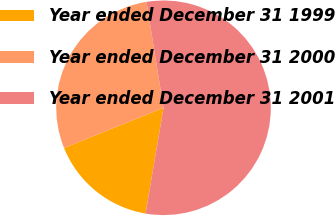Convert chart to OTSL. <chart><loc_0><loc_0><loc_500><loc_500><pie_chart><fcel>Year ended December 31 1999<fcel>Year ended December 31 2000<fcel>Year ended December 31 2001<nl><fcel>16.21%<fcel>28.57%<fcel>55.22%<nl></chart> 